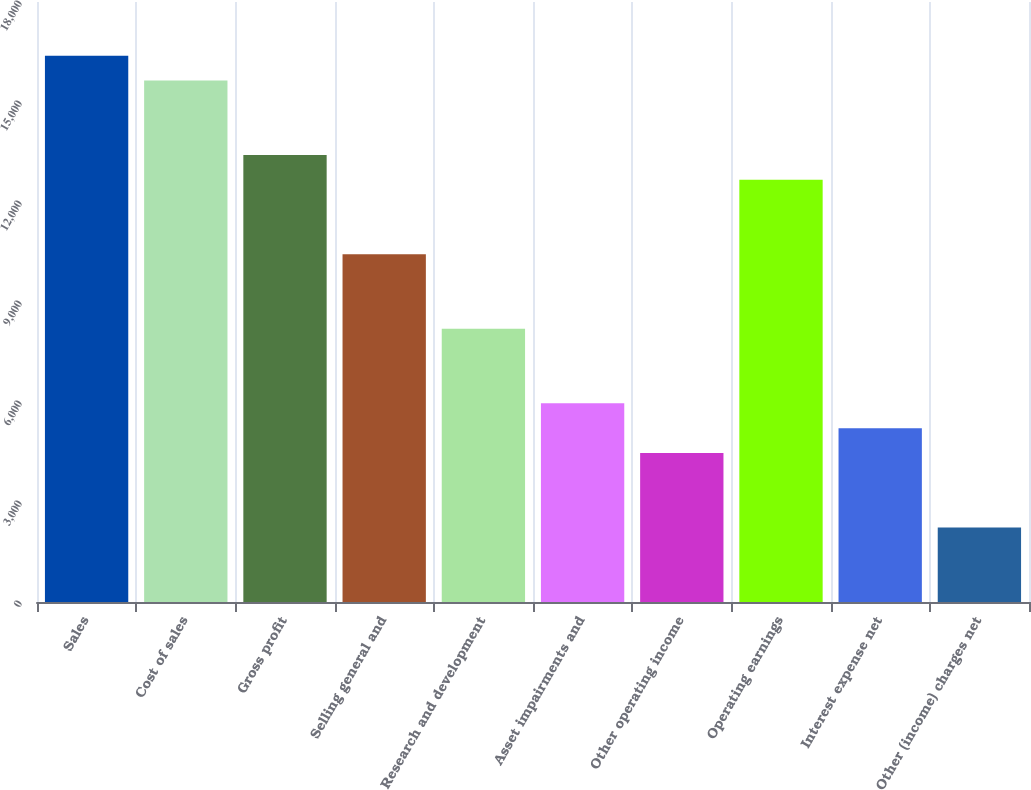<chart> <loc_0><loc_0><loc_500><loc_500><bar_chart><fcel>Sales<fcel>Cost of sales<fcel>Gross profit<fcel>Selling general and<fcel>Research and development<fcel>Asset impairments and<fcel>Other operating income<fcel>Operating earnings<fcel>Interest expense net<fcel>Other (income) charges net<nl><fcel>16388.8<fcel>15643.9<fcel>13409.2<fcel>10429.6<fcel>8194.9<fcel>5960.2<fcel>4470.4<fcel>12664.3<fcel>5215.3<fcel>2235.7<nl></chart> 